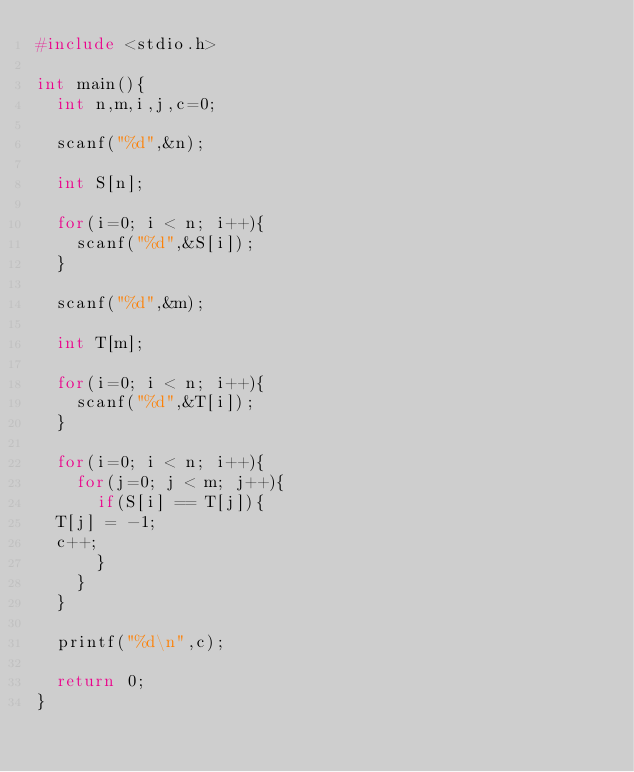<code> <loc_0><loc_0><loc_500><loc_500><_C_>#include <stdio.h>

int main(){
  int n,m,i,j,c=0;

  scanf("%d",&n);

  int S[n];

  for(i=0; i < n; i++){
    scanf("%d",&S[i]);
  }

  scanf("%d",&m);

  int T[m];

  for(i=0; i < n; i++){
    scanf("%d",&T[i]);
  }

  for(i=0; i < n; i++){
    for(j=0; j < m; j++){
      if(S[i] == T[j]){
	T[j] = -1;
	c++;
      }
    }
  }

  printf("%d\n",c);

  return 0;
}


</code> 